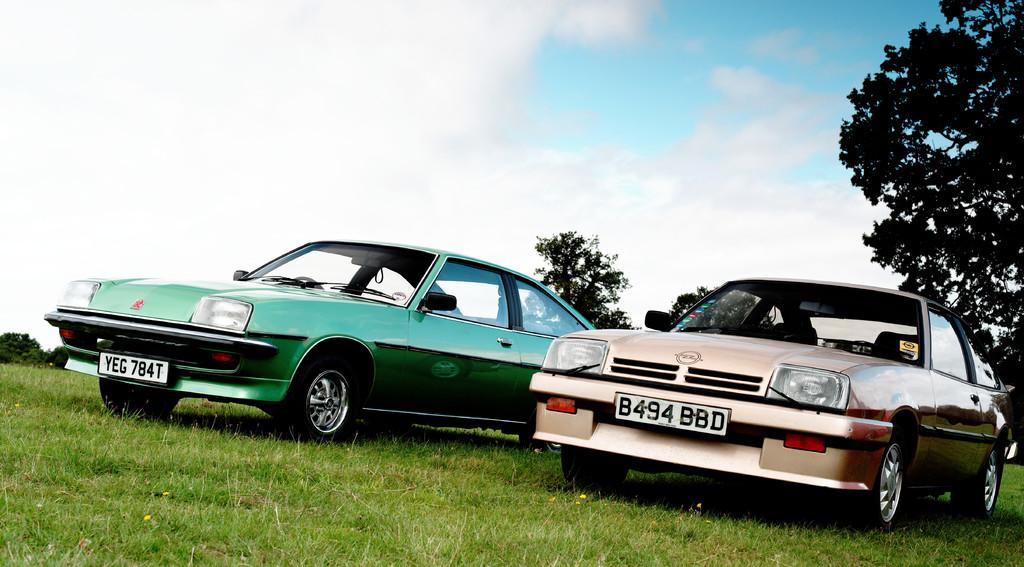What type of vehicles are on the ground in the image? There are cars on the ground in the image. What type of vegetation can be seen in the image? There is grass visible in the image, and there are also trees. What is visible in the background of the image? The sky is visible in the background of the image. What can be seen in the sky in the image? Clouds are present in the sky. How many beans are scattered on the ground in the image? There are no beans present in the image. What type of clocks can be seen hanging from the trees in the image? There are no clocks visible in the image; only cars, grass, trees, and the sky are present. 